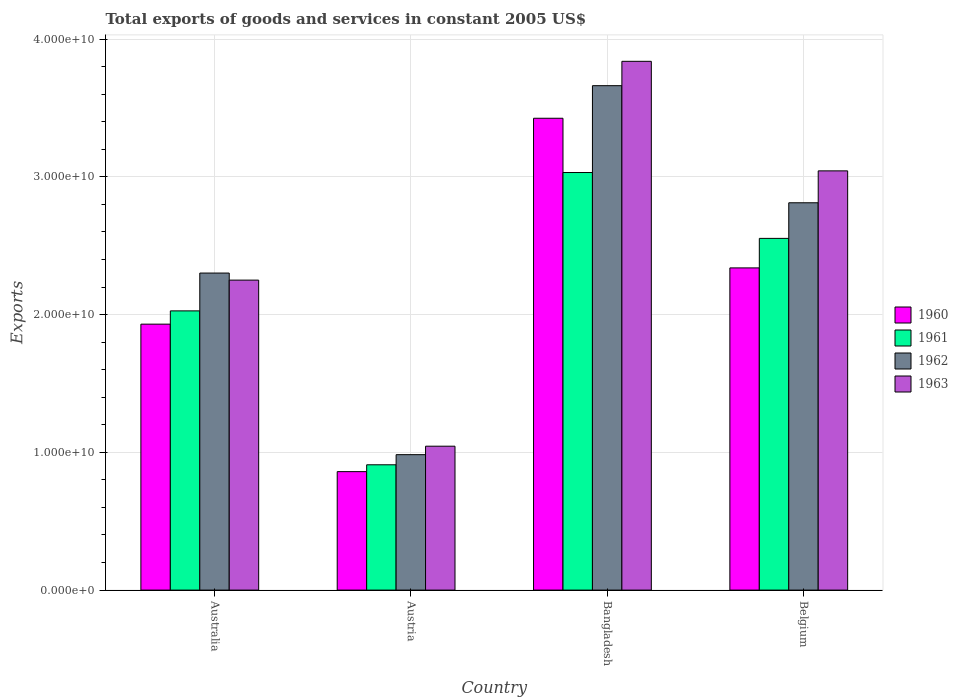How many different coloured bars are there?
Ensure brevity in your answer.  4. How many bars are there on the 2nd tick from the left?
Ensure brevity in your answer.  4. What is the total exports of goods and services in 1963 in Bangladesh?
Keep it short and to the point. 3.84e+1. Across all countries, what is the maximum total exports of goods and services in 1962?
Ensure brevity in your answer.  3.66e+1. Across all countries, what is the minimum total exports of goods and services in 1961?
Give a very brief answer. 9.10e+09. In which country was the total exports of goods and services in 1963 minimum?
Your answer should be very brief. Austria. What is the total total exports of goods and services in 1960 in the graph?
Make the answer very short. 8.55e+1. What is the difference between the total exports of goods and services in 1962 in Australia and that in Bangladesh?
Offer a very short reply. -1.36e+1. What is the difference between the total exports of goods and services in 1960 in Belgium and the total exports of goods and services in 1963 in Austria?
Provide a succinct answer. 1.29e+1. What is the average total exports of goods and services in 1963 per country?
Provide a succinct answer. 2.54e+1. What is the difference between the total exports of goods and services of/in 1962 and total exports of goods and services of/in 1963 in Australia?
Offer a very short reply. 5.13e+08. What is the ratio of the total exports of goods and services in 1961 in Australia to that in Austria?
Your answer should be compact. 2.23. What is the difference between the highest and the second highest total exports of goods and services in 1962?
Give a very brief answer. -1.36e+1. What is the difference between the highest and the lowest total exports of goods and services in 1962?
Provide a succinct answer. 2.68e+1. Is the sum of the total exports of goods and services in 1963 in Australia and Belgium greater than the maximum total exports of goods and services in 1962 across all countries?
Offer a very short reply. Yes. Is it the case that in every country, the sum of the total exports of goods and services in 1963 and total exports of goods and services in 1960 is greater than the sum of total exports of goods and services in 1962 and total exports of goods and services in 1961?
Offer a very short reply. No. What does the 4th bar from the left in Australia represents?
Your answer should be very brief. 1963. What does the 3rd bar from the right in Belgium represents?
Give a very brief answer. 1961. Is it the case that in every country, the sum of the total exports of goods and services in 1963 and total exports of goods and services in 1961 is greater than the total exports of goods and services in 1962?
Provide a succinct answer. Yes. Are all the bars in the graph horizontal?
Your response must be concise. No. How many countries are there in the graph?
Give a very brief answer. 4. What is the difference between two consecutive major ticks on the Y-axis?
Your answer should be compact. 1.00e+1. Does the graph contain grids?
Provide a succinct answer. Yes. How many legend labels are there?
Your answer should be compact. 4. What is the title of the graph?
Keep it short and to the point. Total exports of goods and services in constant 2005 US$. Does "1977" appear as one of the legend labels in the graph?
Provide a succinct answer. No. What is the label or title of the Y-axis?
Provide a short and direct response. Exports. What is the Exports of 1960 in Australia?
Offer a terse response. 1.93e+1. What is the Exports of 1961 in Australia?
Offer a very short reply. 2.03e+1. What is the Exports in 1962 in Australia?
Make the answer very short. 2.30e+1. What is the Exports of 1963 in Australia?
Offer a very short reply. 2.25e+1. What is the Exports in 1960 in Austria?
Your answer should be very brief. 8.60e+09. What is the Exports of 1961 in Austria?
Ensure brevity in your answer.  9.10e+09. What is the Exports of 1962 in Austria?
Give a very brief answer. 9.83e+09. What is the Exports in 1963 in Austria?
Keep it short and to the point. 1.04e+1. What is the Exports in 1960 in Bangladesh?
Provide a short and direct response. 3.42e+1. What is the Exports in 1961 in Bangladesh?
Give a very brief answer. 3.03e+1. What is the Exports in 1962 in Bangladesh?
Give a very brief answer. 3.66e+1. What is the Exports in 1963 in Bangladesh?
Keep it short and to the point. 3.84e+1. What is the Exports of 1960 in Belgium?
Give a very brief answer. 2.34e+1. What is the Exports in 1961 in Belgium?
Ensure brevity in your answer.  2.55e+1. What is the Exports in 1962 in Belgium?
Make the answer very short. 2.81e+1. What is the Exports in 1963 in Belgium?
Your answer should be very brief. 3.04e+1. Across all countries, what is the maximum Exports of 1960?
Provide a succinct answer. 3.42e+1. Across all countries, what is the maximum Exports of 1961?
Offer a very short reply. 3.03e+1. Across all countries, what is the maximum Exports of 1962?
Your answer should be very brief. 3.66e+1. Across all countries, what is the maximum Exports of 1963?
Offer a very short reply. 3.84e+1. Across all countries, what is the minimum Exports of 1960?
Ensure brevity in your answer.  8.60e+09. Across all countries, what is the minimum Exports of 1961?
Keep it short and to the point. 9.10e+09. Across all countries, what is the minimum Exports in 1962?
Offer a very short reply. 9.83e+09. Across all countries, what is the minimum Exports in 1963?
Provide a short and direct response. 1.04e+1. What is the total Exports of 1960 in the graph?
Ensure brevity in your answer.  8.55e+1. What is the total Exports in 1961 in the graph?
Provide a succinct answer. 8.52e+1. What is the total Exports of 1962 in the graph?
Keep it short and to the point. 9.76e+1. What is the total Exports of 1963 in the graph?
Your answer should be very brief. 1.02e+11. What is the difference between the Exports of 1960 in Australia and that in Austria?
Ensure brevity in your answer.  1.07e+1. What is the difference between the Exports in 1961 in Australia and that in Austria?
Your response must be concise. 1.12e+1. What is the difference between the Exports of 1962 in Australia and that in Austria?
Offer a very short reply. 1.32e+1. What is the difference between the Exports of 1963 in Australia and that in Austria?
Provide a short and direct response. 1.21e+1. What is the difference between the Exports in 1960 in Australia and that in Bangladesh?
Give a very brief answer. -1.49e+1. What is the difference between the Exports in 1961 in Australia and that in Bangladesh?
Your answer should be very brief. -1.00e+1. What is the difference between the Exports of 1962 in Australia and that in Bangladesh?
Ensure brevity in your answer.  -1.36e+1. What is the difference between the Exports in 1963 in Australia and that in Bangladesh?
Ensure brevity in your answer.  -1.59e+1. What is the difference between the Exports in 1960 in Australia and that in Belgium?
Give a very brief answer. -4.08e+09. What is the difference between the Exports in 1961 in Australia and that in Belgium?
Provide a short and direct response. -5.26e+09. What is the difference between the Exports of 1962 in Australia and that in Belgium?
Provide a short and direct response. -5.10e+09. What is the difference between the Exports in 1963 in Australia and that in Belgium?
Offer a terse response. -7.93e+09. What is the difference between the Exports in 1960 in Austria and that in Bangladesh?
Your answer should be compact. -2.57e+1. What is the difference between the Exports of 1961 in Austria and that in Bangladesh?
Give a very brief answer. -2.12e+1. What is the difference between the Exports in 1962 in Austria and that in Bangladesh?
Your response must be concise. -2.68e+1. What is the difference between the Exports of 1963 in Austria and that in Bangladesh?
Give a very brief answer. -2.79e+1. What is the difference between the Exports of 1960 in Austria and that in Belgium?
Make the answer very short. -1.48e+1. What is the difference between the Exports of 1961 in Austria and that in Belgium?
Provide a short and direct response. -1.64e+1. What is the difference between the Exports of 1962 in Austria and that in Belgium?
Provide a short and direct response. -1.83e+1. What is the difference between the Exports of 1963 in Austria and that in Belgium?
Offer a very short reply. -2.00e+1. What is the difference between the Exports in 1960 in Bangladesh and that in Belgium?
Your response must be concise. 1.09e+1. What is the difference between the Exports of 1961 in Bangladesh and that in Belgium?
Provide a succinct answer. 4.78e+09. What is the difference between the Exports in 1962 in Bangladesh and that in Belgium?
Keep it short and to the point. 8.50e+09. What is the difference between the Exports in 1963 in Bangladesh and that in Belgium?
Provide a short and direct response. 7.95e+09. What is the difference between the Exports of 1960 in Australia and the Exports of 1961 in Austria?
Your response must be concise. 1.02e+1. What is the difference between the Exports in 1960 in Australia and the Exports in 1962 in Austria?
Your response must be concise. 9.47e+09. What is the difference between the Exports of 1960 in Australia and the Exports of 1963 in Austria?
Offer a very short reply. 8.86e+09. What is the difference between the Exports of 1961 in Australia and the Exports of 1962 in Austria?
Provide a short and direct response. 1.04e+1. What is the difference between the Exports in 1961 in Australia and the Exports in 1963 in Austria?
Provide a short and direct response. 9.82e+09. What is the difference between the Exports of 1962 in Australia and the Exports of 1963 in Austria?
Offer a terse response. 1.26e+1. What is the difference between the Exports of 1960 in Australia and the Exports of 1961 in Bangladesh?
Keep it short and to the point. -1.10e+1. What is the difference between the Exports of 1960 in Australia and the Exports of 1962 in Bangladesh?
Make the answer very short. -1.73e+1. What is the difference between the Exports of 1960 in Australia and the Exports of 1963 in Bangladesh?
Make the answer very short. -1.91e+1. What is the difference between the Exports of 1961 in Australia and the Exports of 1962 in Bangladesh?
Ensure brevity in your answer.  -1.63e+1. What is the difference between the Exports of 1961 in Australia and the Exports of 1963 in Bangladesh?
Keep it short and to the point. -1.81e+1. What is the difference between the Exports of 1962 in Australia and the Exports of 1963 in Bangladesh?
Make the answer very short. -1.54e+1. What is the difference between the Exports in 1960 in Australia and the Exports in 1961 in Belgium?
Keep it short and to the point. -6.23e+09. What is the difference between the Exports in 1960 in Australia and the Exports in 1962 in Belgium?
Your answer should be very brief. -8.81e+09. What is the difference between the Exports of 1960 in Australia and the Exports of 1963 in Belgium?
Keep it short and to the point. -1.11e+1. What is the difference between the Exports in 1961 in Australia and the Exports in 1962 in Belgium?
Your answer should be compact. -7.85e+09. What is the difference between the Exports of 1961 in Australia and the Exports of 1963 in Belgium?
Offer a very short reply. -1.02e+1. What is the difference between the Exports of 1962 in Australia and the Exports of 1963 in Belgium?
Keep it short and to the point. -7.42e+09. What is the difference between the Exports in 1960 in Austria and the Exports in 1961 in Bangladesh?
Keep it short and to the point. -2.17e+1. What is the difference between the Exports in 1960 in Austria and the Exports in 1962 in Bangladesh?
Give a very brief answer. -2.80e+1. What is the difference between the Exports of 1960 in Austria and the Exports of 1963 in Bangladesh?
Provide a succinct answer. -2.98e+1. What is the difference between the Exports of 1961 in Austria and the Exports of 1962 in Bangladesh?
Give a very brief answer. -2.75e+1. What is the difference between the Exports in 1961 in Austria and the Exports in 1963 in Bangladesh?
Offer a terse response. -2.93e+1. What is the difference between the Exports of 1962 in Austria and the Exports of 1963 in Bangladesh?
Provide a succinct answer. -2.86e+1. What is the difference between the Exports in 1960 in Austria and the Exports in 1961 in Belgium?
Ensure brevity in your answer.  -1.69e+1. What is the difference between the Exports of 1960 in Austria and the Exports of 1962 in Belgium?
Provide a succinct answer. -1.95e+1. What is the difference between the Exports of 1960 in Austria and the Exports of 1963 in Belgium?
Offer a very short reply. -2.18e+1. What is the difference between the Exports of 1961 in Austria and the Exports of 1962 in Belgium?
Your response must be concise. -1.90e+1. What is the difference between the Exports of 1961 in Austria and the Exports of 1963 in Belgium?
Your response must be concise. -2.13e+1. What is the difference between the Exports in 1962 in Austria and the Exports in 1963 in Belgium?
Your answer should be very brief. -2.06e+1. What is the difference between the Exports in 1960 in Bangladesh and the Exports in 1961 in Belgium?
Offer a terse response. 8.72e+09. What is the difference between the Exports of 1960 in Bangladesh and the Exports of 1962 in Belgium?
Give a very brief answer. 6.14e+09. What is the difference between the Exports in 1960 in Bangladesh and the Exports in 1963 in Belgium?
Make the answer very short. 3.82e+09. What is the difference between the Exports of 1961 in Bangladesh and the Exports of 1962 in Belgium?
Your response must be concise. 2.20e+09. What is the difference between the Exports of 1961 in Bangladesh and the Exports of 1963 in Belgium?
Offer a very short reply. -1.20e+08. What is the difference between the Exports in 1962 in Bangladesh and the Exports in 1963 in Belgium?
Your answer should be very brief. 6.18e+09. What is the average Exports in 1960 per country?
Offer a terse response. 2.14e+1. What is the average Exports in 1961 per country?
Provide a short and direct response. 2.13e+1. What is the average Exports of 1962 per country?
Provide a succinct answer. 2.44e+1. What is the average Exports in 1963 per country?
Your answer should be very brief. 2.54e+1. What is the difference between the Exports of 1960 and Exports of 1961 in Australia?
Ensure brevity in your answer.  -9.63e+08. What is the difference between the Exports in 1960 and Exports in 1962 in Australia?
Offer a terse response. -3.71e+09. What is the difference between the Exports of 1960 and Exports of 1963 in Australia?
Your answer should be very brief. -3.20e+09. What is the difference between the Exports of 1961 and Exports of 1962 in Australia?
Offer a terse response. -2.75e+09. What is the difference between the Exports in 1961 and Exports in 1963 in Australia?
Offer a very short reply. -2.23e+09. What is the difference between the Exports of 1962 and Exports of 1963 in Australia?
Your answer should be compact. 5.13e+08. What is the difference between the Exports of 1960 and Exports of 1961 in Austria?
Provide a short and direct response. -4.96e+08. What is the difference between the Exports in 1960 and Exports in 1962 in Austria?
Ensure brevity in your answer.  -1.23e+09. What is the difference between the Exports of 1960 and Exports of 1963 in Austria?
Ensure brevity in your answer.  -1.85e+09. What is the difference between the Exports in 1961 and Exports in 1962 in Austria?
Your answer should be compact. -7.35e+08. What is the difference between the Exports of 1961 and Exports of 1963 in Austria?
Give a very brief answer. -1.35e+09. What is the difference between the Exports in 1962 and Exports in 1963 in Austria?
Your answer should be very brief. -6.16e+08. What is the difference between the Exports in 1960 and Exports in 1961 in Bangladesh?
Your answer should be very brief. 3.94e+09. What is the difference between the Exports of 1960 and Exports of 1962 in Bangladesh?
Your answer should be very brief. -2.36e+09. What is the difference between the Exports in 1960 and Exports in 1963 in Bangladesh?
Ensure brevity in your answer.  -4.13e+09. What is the difference between the Exports of 1961 and Exports of 1962 in Bangladesh?
Make the answer very short. -6.30e+09. What is the difference between the Exports in 1961 and Exports in 1963 in Bangladesh?
Make the answer very short. -8.07e+09. What is the difference between the Exports of 1962 and Exports of 1963 in Bangladesh?
Provide a succinct answer. -1.77e+09. What is the difference between the Exports in 1960 and Exports in 1961 in Belgium?
Provide a succinct answer. -2.14e+09. What is the difference between the Exports in 1960 and Exports in 1962 in Belgium?
Your answer should be compact. -4.73e+09. What is the difference between the Exports in 1960 and Exports in 1963 in Belgium?
Your response must be concise. -7.04e+09. What is the difference between the Exports in 1961 and Exports in 1962 in Belgium?
Your answer should be compact. -2.58e+09. What is the difference between the Exports in 1961 and Exports in 1963 in Belgium?
Keep it short and to the point. -4.90e+09. What is the difference between the Exports in 1962 and Exports in 1963 in Belgium?
Give a very brief answer. -2.32e+09. What is the ratio of the Exports in 1960 in Australia to that in Austria?
Ensure brevity in your answer.  2.25. What is the ratio of the Exports of 1961 in Australia to that in Austria?
Your answer should be very brief. 2.23. What is the ratio of the Exports of 1962 in Australia to that in Austria?
Offer a very short reply. 2.34. What is the ratio of the Exports of 1963 in Australia to that in Austria?
Offer a terse response. 2.15. What is the ratio of the Exports of 1960 in Australia to that in Bangladesh?
Your response must be concise. 0.56. What is the ratio of the Exports in 1961 in Australia to that in Bangladesh?
Ensure brevity in your answer.  0.67. What is the ratio of the Exports of 1962 in Australia to that in Bangladesh?
Ensure brevity in your answer.  0.63. What is the ratio of the Exports in 1963 in Australia to that in Bangladesh?
Offer a very short reply. 0.59. What is the ratio of the Exports of 1960 in Australia to that in Belgium?
Your response must be concise. 0.83. What is the ratio of the Exports in 1961 in Australia to that in Belgium?
Give a very brief answer. 0.79. What is the ratio of the Exports in 1962 in Australia to that in Belgium?
Your response must be concise. 0.82. What is the ratio of the Exports of 1963 in Australia to that in Belgium?
Provide a succinct answer. 0.74. What is the ratio of the Exports in 1960 in Austria to that in Bangladesh?
Offer a very short reply. 0.25. What is the ratio of the Exports of 1961 in Austria to that in Bangladesh?
Your answer should be very brief. 0.3. What is the ratio of the Exports in 1962 in Austria to that in Bangladesh?
Offer a very short reply. 0.27. What is the ratio of the Exports of 1963 in Austria to that in Bangladesh?
Offer a very short reply. 0.27. What is the ratio of the Exports of 1960 in Austria to that in Belgium?
Provide a short and direct response. 0.37. What is the ratio of the Exports in 1961 in Austria to that in Belgium?
Provide a short and direct response. 0.36. What is the ratio of the Exports of 1962 in Austria to that in Belgium?
Your response must be concise. 0.35. What is the ratio of the Exports in 1963 in Austria to that in Belgium?
Your answer should be very brief. 0.34. What is the ratio of the Exports of 1960 in Bangladesh to that in Belgium?
Give a very brief answer. 1.46. What is the ratio of the Exports in 1961 in Bangladesh to that in Belgium?
Offer a terse response. 1.19. What is the ratio of the Exports of 1962 in Bangladesh to that in Belgium?
Provide a short and direct response. 1.3. What is the ratio of the Exports of 1963 in Bangladesh to that in Belgium?
Keep it short and to the point. 1.26. What is the difference between the highest and the second highest Exports of 1960?
Ensure brevity in your answer.  1.09e+1. What is the difference between the highest and the second highest Exports in 1961?
Your answer should be compact. 4.78e+09. What is the difference between the highest and the second highest Exports in 1962?
Give a very brief answer. 8.50e+09. What is the difference between the highest and the second highest Exports of 1963?
Offer a very short reply. 7.95e+09. What is the difference between the highest and the lowest Exports of 1960?
Provide a short and direct response. 2.57e+1. What is the difference between the highest and the lowest Exports in 1961?
Make the answer very short. 2.12e+1. What is the difference between the highest and the lowest Exports in 1962?
Your answer should be compact. 2.68e+1. What is the difference between the highest and the lowest Exports in 1963?
Make the answer very short. 2.79e+1. 